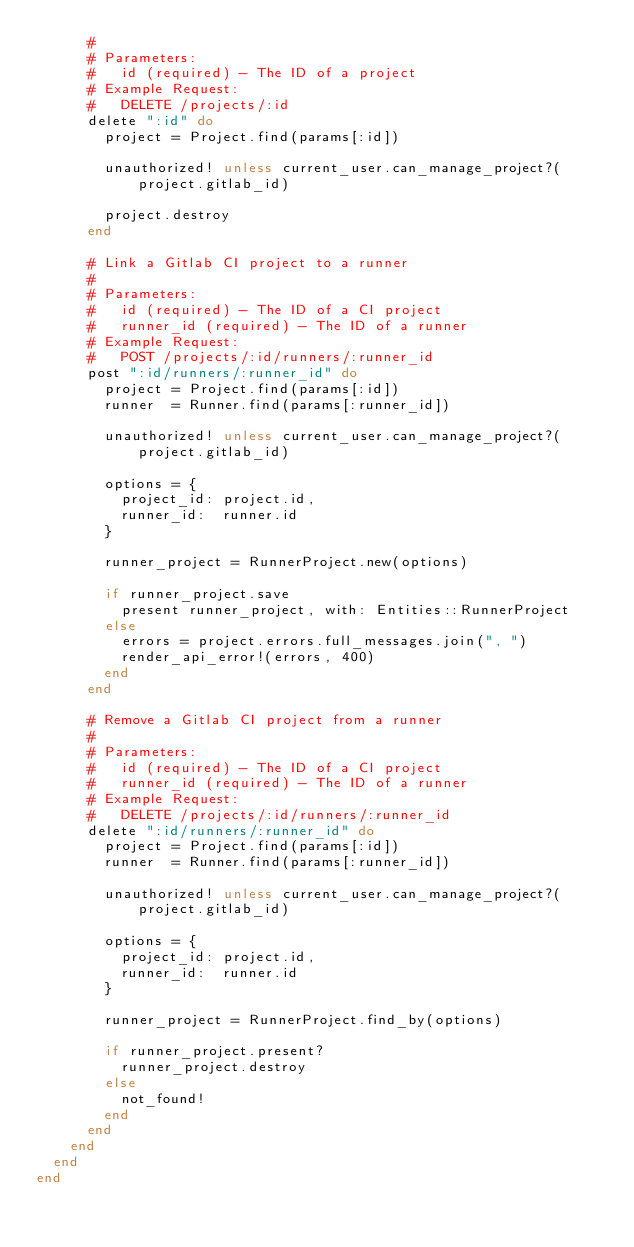<code> <loc_0><loc_0><loc_500><loc_500><_Ruby_>      #
      # Parameters:
      #   id (required) - The ID of a project
      # Example Request:
      #   DELETE /projects/:id
      delete ":id" do
        project = Project.find(params[:id])

        unauthorized! unless current_user.can_manage_project?(project.gitlab_id)

        project.destroy
      end

      # Link a Gitlab CI project to a runner
      #
      # Parameters:
      #   id (required) - The ID of a CI project
      #   runner_id (required) - The ID of a runner
      # Example Request:
      #   POST /projects/:id/runners/:runner_id
      post ":id/runners/:runner_id" do
        project = Project.find(params[:id])
        runner  = Runner.find(params[:runner_id])

        unauthorized! unless current_user.can_manage_project?(project.gitlab_id)

        options = {
          project_id: project.id,
          runner_id:  runner.id
        }

        runner_project = RunnerProject.new(options)

        if runner_project.save
          present runner_project, with: Entities::RunnerProject
        else
          errors = project.errors.full_messages.join(", ")
          render_api_error!(errors, 400)
        end
      end

      # Remove a Gitlab CI project from a runner
      #
      # Parameters:
      #   id (required) - The ID of a CI project
      #   runner_id (required) - The ID of a runner
      # Example Request:
      #   DELETE /projects/:id/runners/:runner_id
      delete ":id/runners/:runner_id" do
        project = Project.find(params[:id])
        runner  = Runner.find(params[:runner_id])

        unauthorized! unless current_user.can_manage_project?(project.gitlab_id)

        options = {
          project_id: project.id,
          runner_id:  runner.id
        }

        runner_project = RunnerProject.find_by(options)

        if runner_project.present?
          runner_project.destroy
        else
          not_found!
        end
      end
    end
  end
end
</code> 